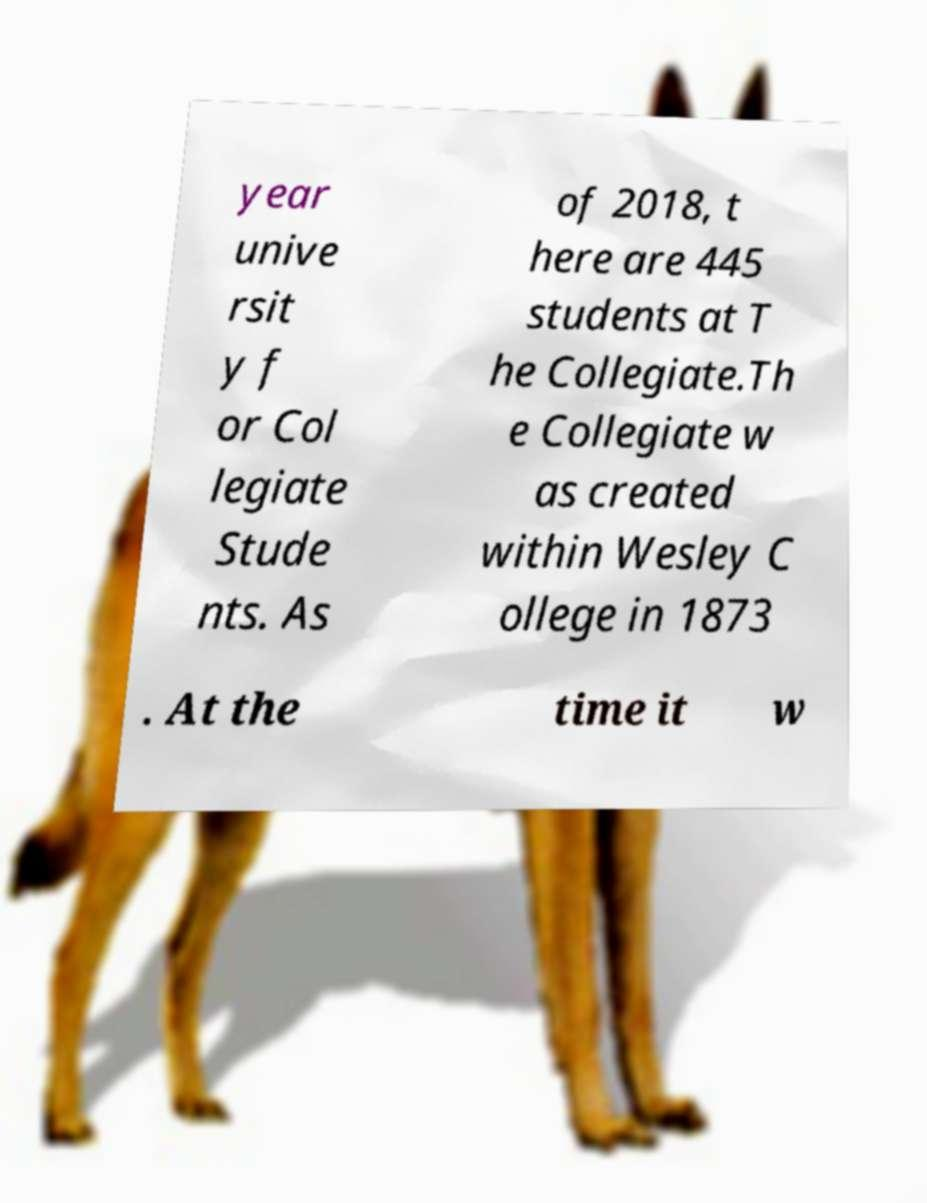For documentation purposes, I need the text within this image transcribed. Could you provide that? year unive rsit y f or Col legiate Stude nts. As of 2018, t here are 445 students at T he Collegiate.Th e Collegiate w as created within Wesley C ollege in 1873 . At the time it w 